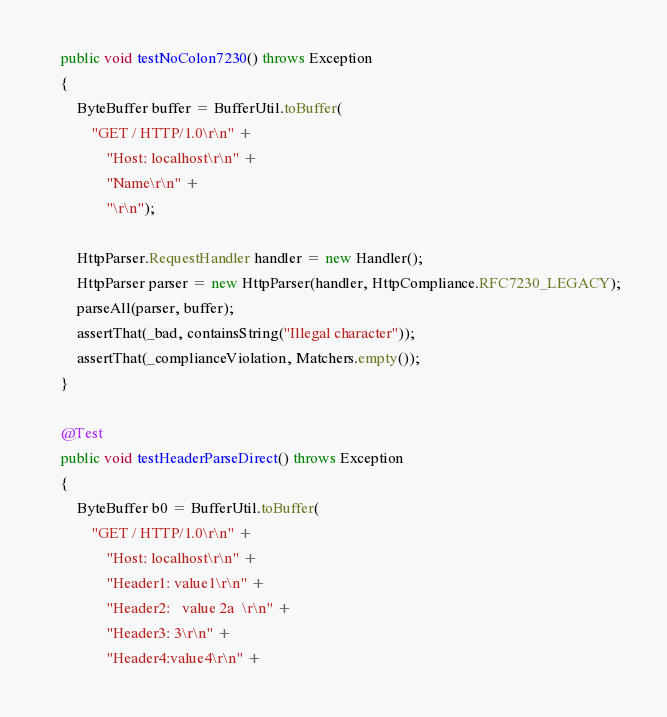Convert code to text. <code><loc_0><loc_0><loc_500><loc_500><_Java_>    public void testNoColon7230() throws Exception
    {
        ByteBuffer buffer = BufferUtil.toBuffer(
            "GET / HTTP/1.0\r\n" +
                "Host: localhost\r\n" +
                "Name\r\n" +
                "\r\n");

        HttpParser.RequestHandler handler = new Handler();
        HttpParser parser = new HttpParser(handler, HttpCompliance.RFC7230_LEGACY);
        parseAll(parser, buffer);
        assertThat(_bad, containsString("Illegal character"));
        assertThat(_complianceViolation, Matchers.empty());
    }

    @Test
    public void testHeaderParseDirect() throws Exception
    {
        ByteBuffer b0 = BufferUtil.toBuffer(
            "GET / HTTP/1.0\r\n" +
                "Host: localhost\r\n" +
                "Header1: value1\r\n" +
                "Header2:   value 2a  \r\n" +
                "Header3: 3\r\n" +
                "Header4:value4\r\n" +</code> 